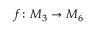<formula> <loc_0><loc_0><loc_500><loc_500>f \colon M _ { 3 } \to M _ { 6 }</formula> 